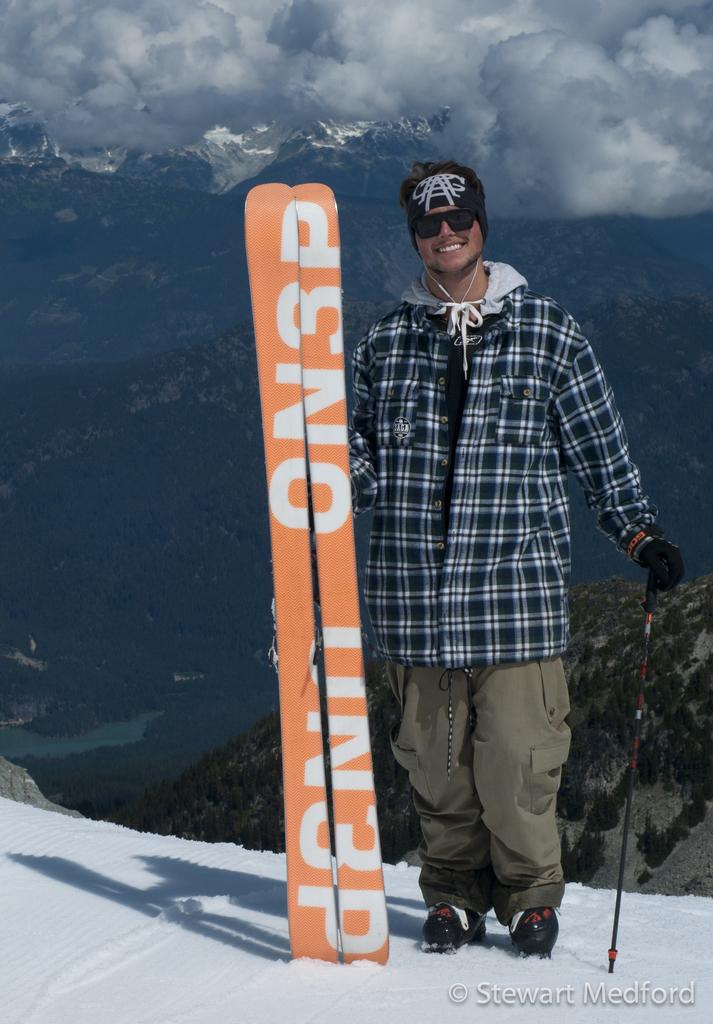Who is present in the image? There is a man in the image. What is the man holding in the image? The man is holding a trekking kit. What is the man's facial expression in the image? The man is smiling in the image. What is the man doing in the image? The man is posing for a photograph. What color is the bear's eye in the image? There is no bear present in the image, so it is not possible to answer that question. 